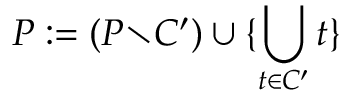<formula> <loc_0><loc_0><loc_500><loc_500>P \colon = ( P { \ } C ^ { \prime } ) \cup \{ \bigcup _ { t \in C ^ { \prime } } t \}</formula> 